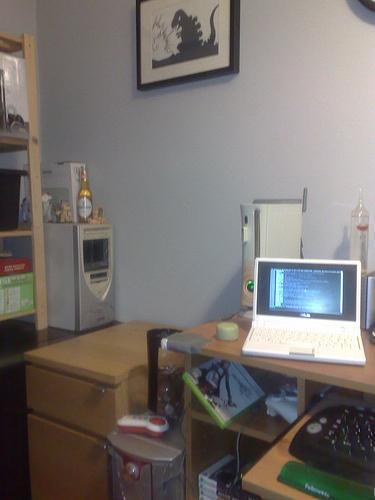How many computers are in the photo?
Give a very brief answer. 1. 